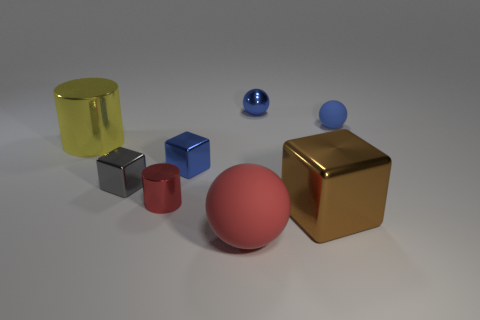Is there anything else that is the same color as the large sphere?
Make the answer very short. Yes. What shape is the large brown object?
Offer a very short reply. Cube. What number of large things are both on the left side of the metallic sphere and right of the metal ball?
Provide a succinct answer. 0. Does the metallic sphere have the same color as the small rubber object?
Make the answer very short. Yes. There is a yellow thing that is the same shape as the small red shiny object; what is it made of?
Offer a terse response. Metal. Is the number of blue metal blocks to the left of the gray metallic thing the same as the number of matte things that are in front of the brown metallic block?
Offer a terse response. No. Do the brown object and the yellow thing have the same material?
Offer a terse response. Yes. How many yellow objects are either big cylinders or tiny objects?
Your answer should be compact. 1. How many large gray objects are the same shape as the small rubber thing?
Give a very brief answer. 0. What material is the red sphere?
Provide a short and direct response. Rubber. 